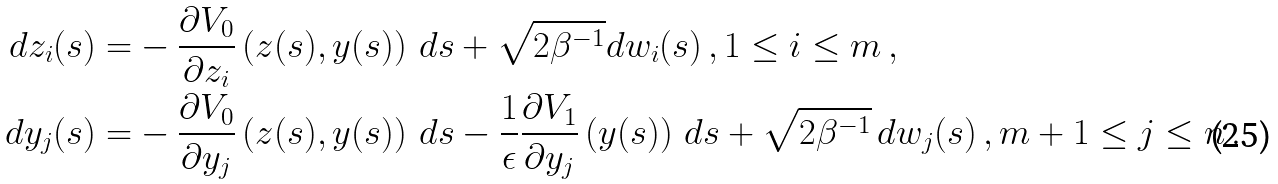<formula> <loc_0><loc_0><loc_500><loc_500>d z _ { i } ( s ) = & - \frac { \partial V _ { 0 } } { \partial z _ { i } } \left ( z ( s ) , y ( s ) \right ) \, d s + \sqrt { 2 \beta ^ { - 1 } } d w _ { i } ( s ) \, , 1 \leq i \leq m \, , \\ d y _ { j } ( s ) = & - \frac { \partial V _ { 0 } } { \partial y _ { j } } \left ( z ( s ) , y ( s ) \right ) \, d s - \frac { 1 } { \epsilon } \frac { \partial V _ { 1 } } { \partial y _ { j } } \left ( y ( s ) \right ) \, d s + \sqrt { 2 \beta ^ { - 1 } } \, d w _ { j } ( s ) \, , m + 1 \leq j \leq n \, .</formula> 